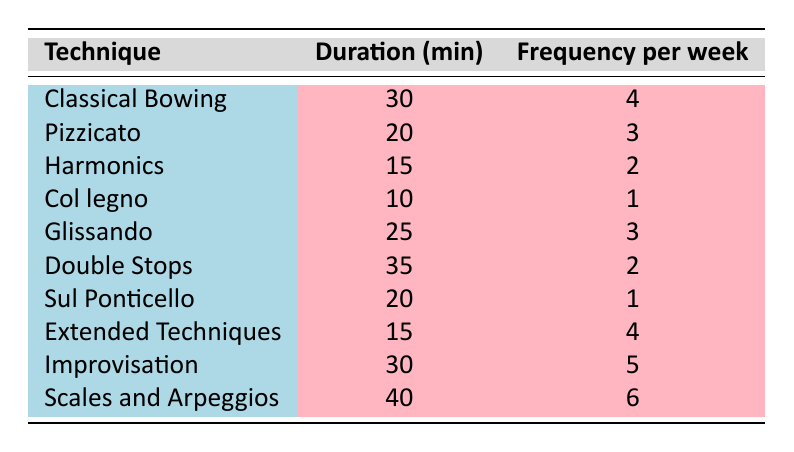What is the duration for Scales and Arpeggios? The table shows that the duration for the technique "Scales and Arpeggios" is 40 minutes.
Answer: 40 minutes How many times per week do you practice Improvisation? Referring to the table, the frequency of practicing "Improvisation" is 5 times per week.
Answer: 5 times per week What technique has the longest practice duration? By comparing the duration values for all techniques, "Scales and Arpeggios" has the longest duration at 40 minutes.
Answer: Scales and Arpeggios Is the frequency of practicing Col legno equal to the frequency of practicing Sul Ponticello? The frequency for "Col legno" is 1, and for "Sul Ponticello," it is also 1, so they are equal.
Answer: Yes What is the total duration of all practice sessions? To find the total duration, sum the individual durations: 30 + 20 + 15 + 10 + 25 + 35 + 20 + 15 + 30 + 40 = 300 minutes total.
Answer: 300 minutes Which technique has a higher frequency: Pizzicato or Glissando? Comparing their frequencies shows "Pizzicato" has 3 times per week and "Glissando" has 3 as well; they are equal.
Answer: They are equal What is the average frequency of all practice techniques? To find the average, first sum the frequencies: 4 + 3 + 2 + 1 + 3 + 2 + 1 + 4 + 5 + 6 = 31. Then divide by 10 (the number of techniques), which gives 3.1.
Answer: 3.1 Which technique is practiced the least in terms of frequency? The table shows that both "Col legno" and "Sul Ponticello" are practiced 1 time per week, making them the least frequent techniques practiced.
Answer: Col legno and Sul Ponticello How many more minutes are spent practicing Double Stops than Harmonics? The duration for "Double Stops" is 35 minutes and for "Harmonics" it is 15 minutes. The difference is 35 - 15 = 20 minutes.
Answer: 20 minutes 